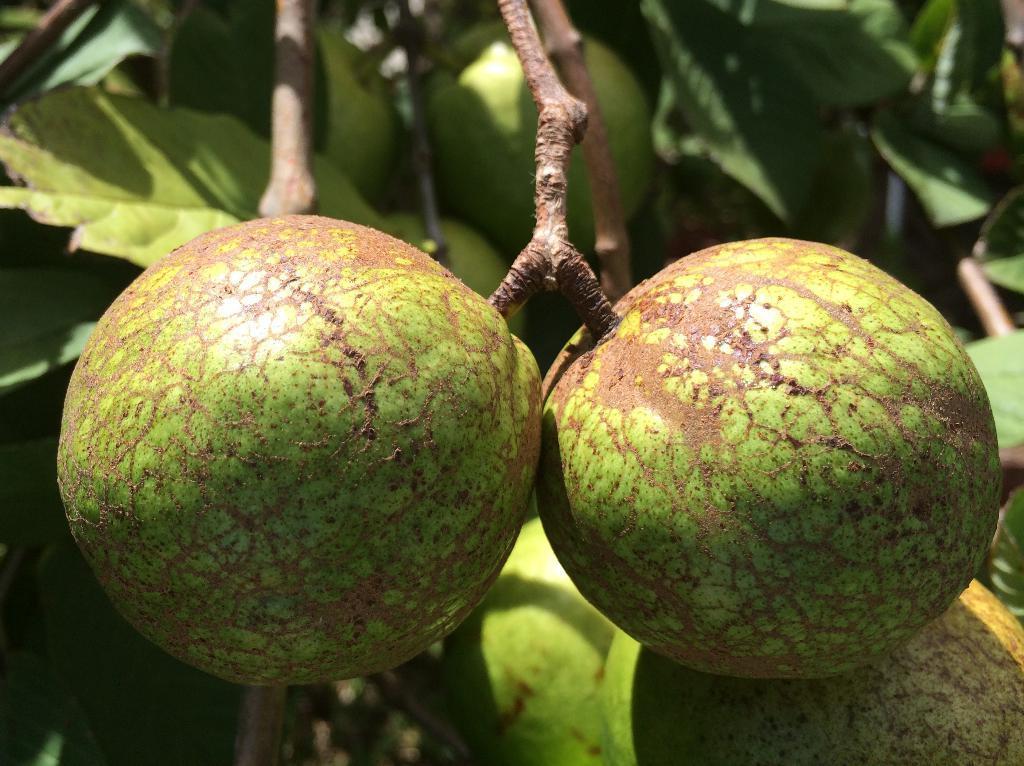How would you summarize this image in a sentence or two? In this image there is a tree and we can see fruits to it. 